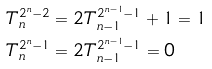<formula> <loc_0><loc_0><loc_500><loc_500>T ^ { 2 ^ { n } - 2 } _ { n } & = 2 T ^ { 2 ^ { n - 1 } - 1 } _ { n - 1 } + 1 = 1 \\ T ^ { 2 ^ { n } - 1 } _ { n } & = 2 T ^ { 2 ^ { n - 1 } - 1 } _ { n - 1 } = 0</formula> 